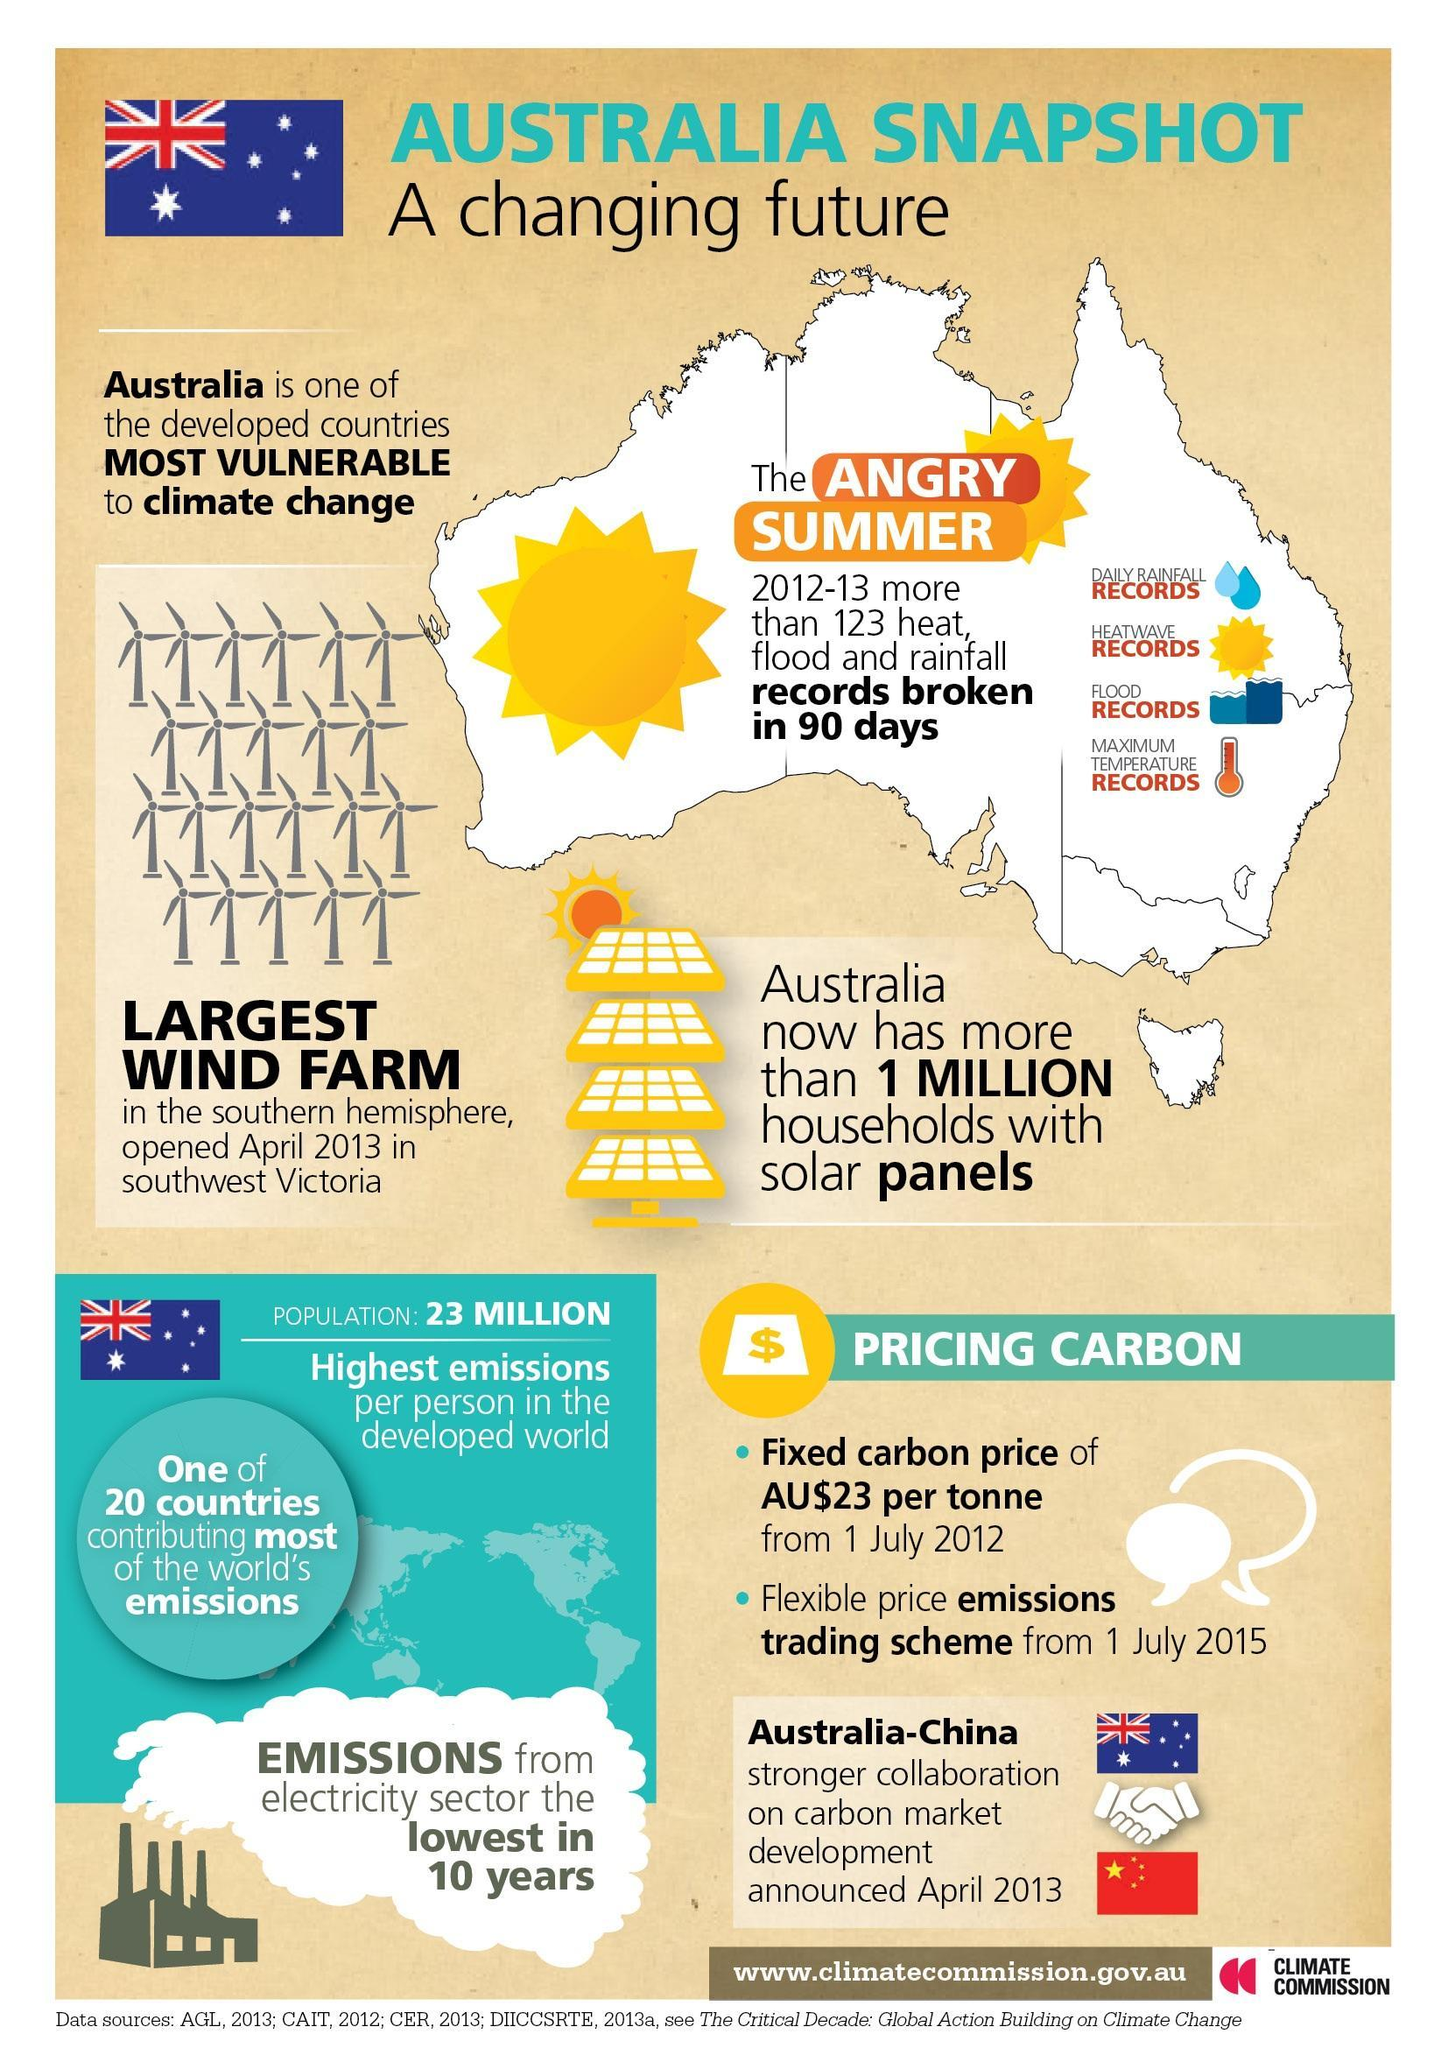Where is the largest wind farm located?
Answer the question with a short phrase. southwest Victoria What is the symbol of Australian Dollar? AU$ 